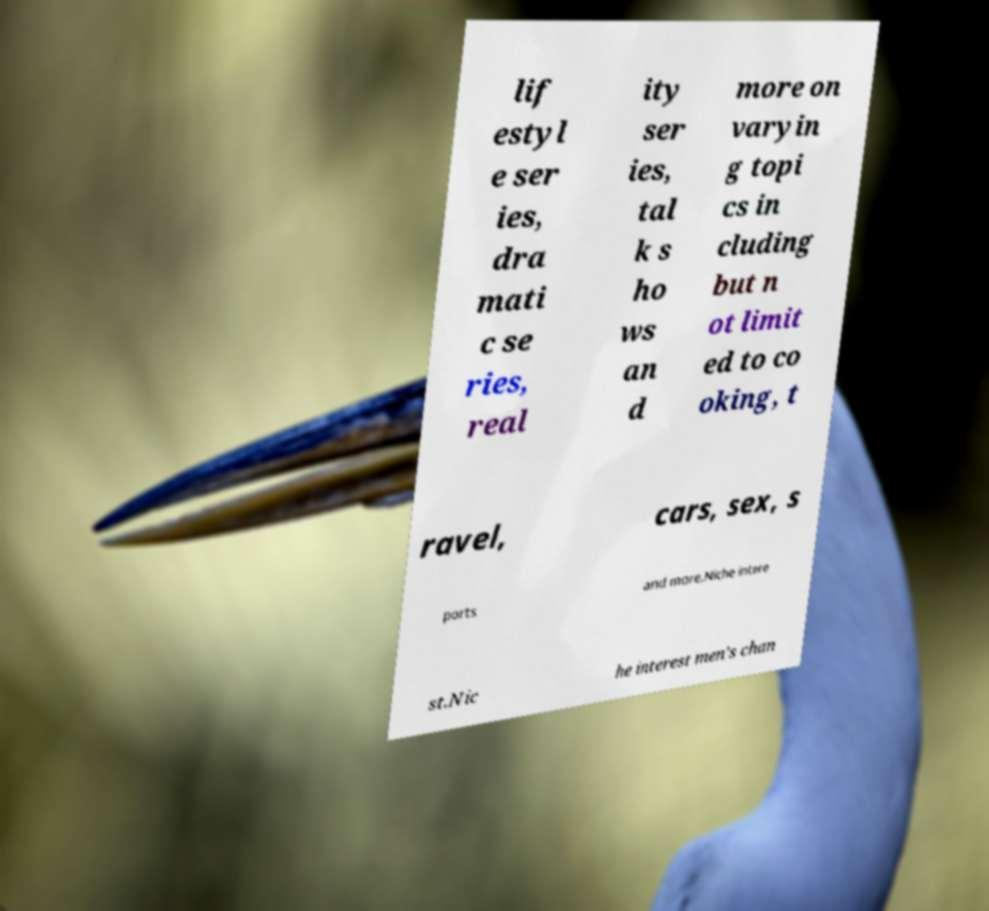Can you accurately transcribe the text from the provided image for me? lif estyl e ser ies, dra mati c se ries, real ity ser ies, tal k s ho ws an d more on varyin g topi cs in cluding but n ot limit ed to co oking, t ravel, cars, sex, s ports and more.Niche intere st.Nic he interest men's chan 